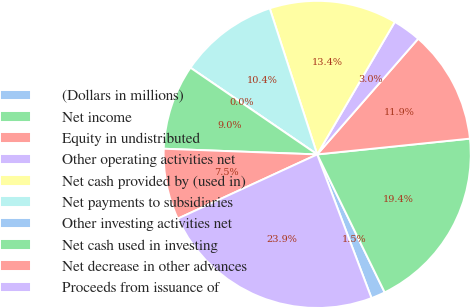Convert chart to OTSL. <chart><loc_0><loc_0><loc_500><loc_500><pie_chart><fcel>(Dollars in millions)<fcel>Net income<fcel>Equity in undistributed<fcel>Other operating activities net<fcel>Net cash provided by (used in)<fcel>Net payments to subsidiaries<fcel>Other investing activities net<fcel>Net cash used in investing<fcel>Net decrease in other advances<fcel>Proceeds from issuance of<nl><fcel>1.49%<fcel>19.4%<fcel>11.94%<fcel>2.99%<fcel>13.43%<fcel>10.45%<fcel>0.0%<fcel>8.96%<fcel>7.46%<fcel>23.88%<nl></chart> 